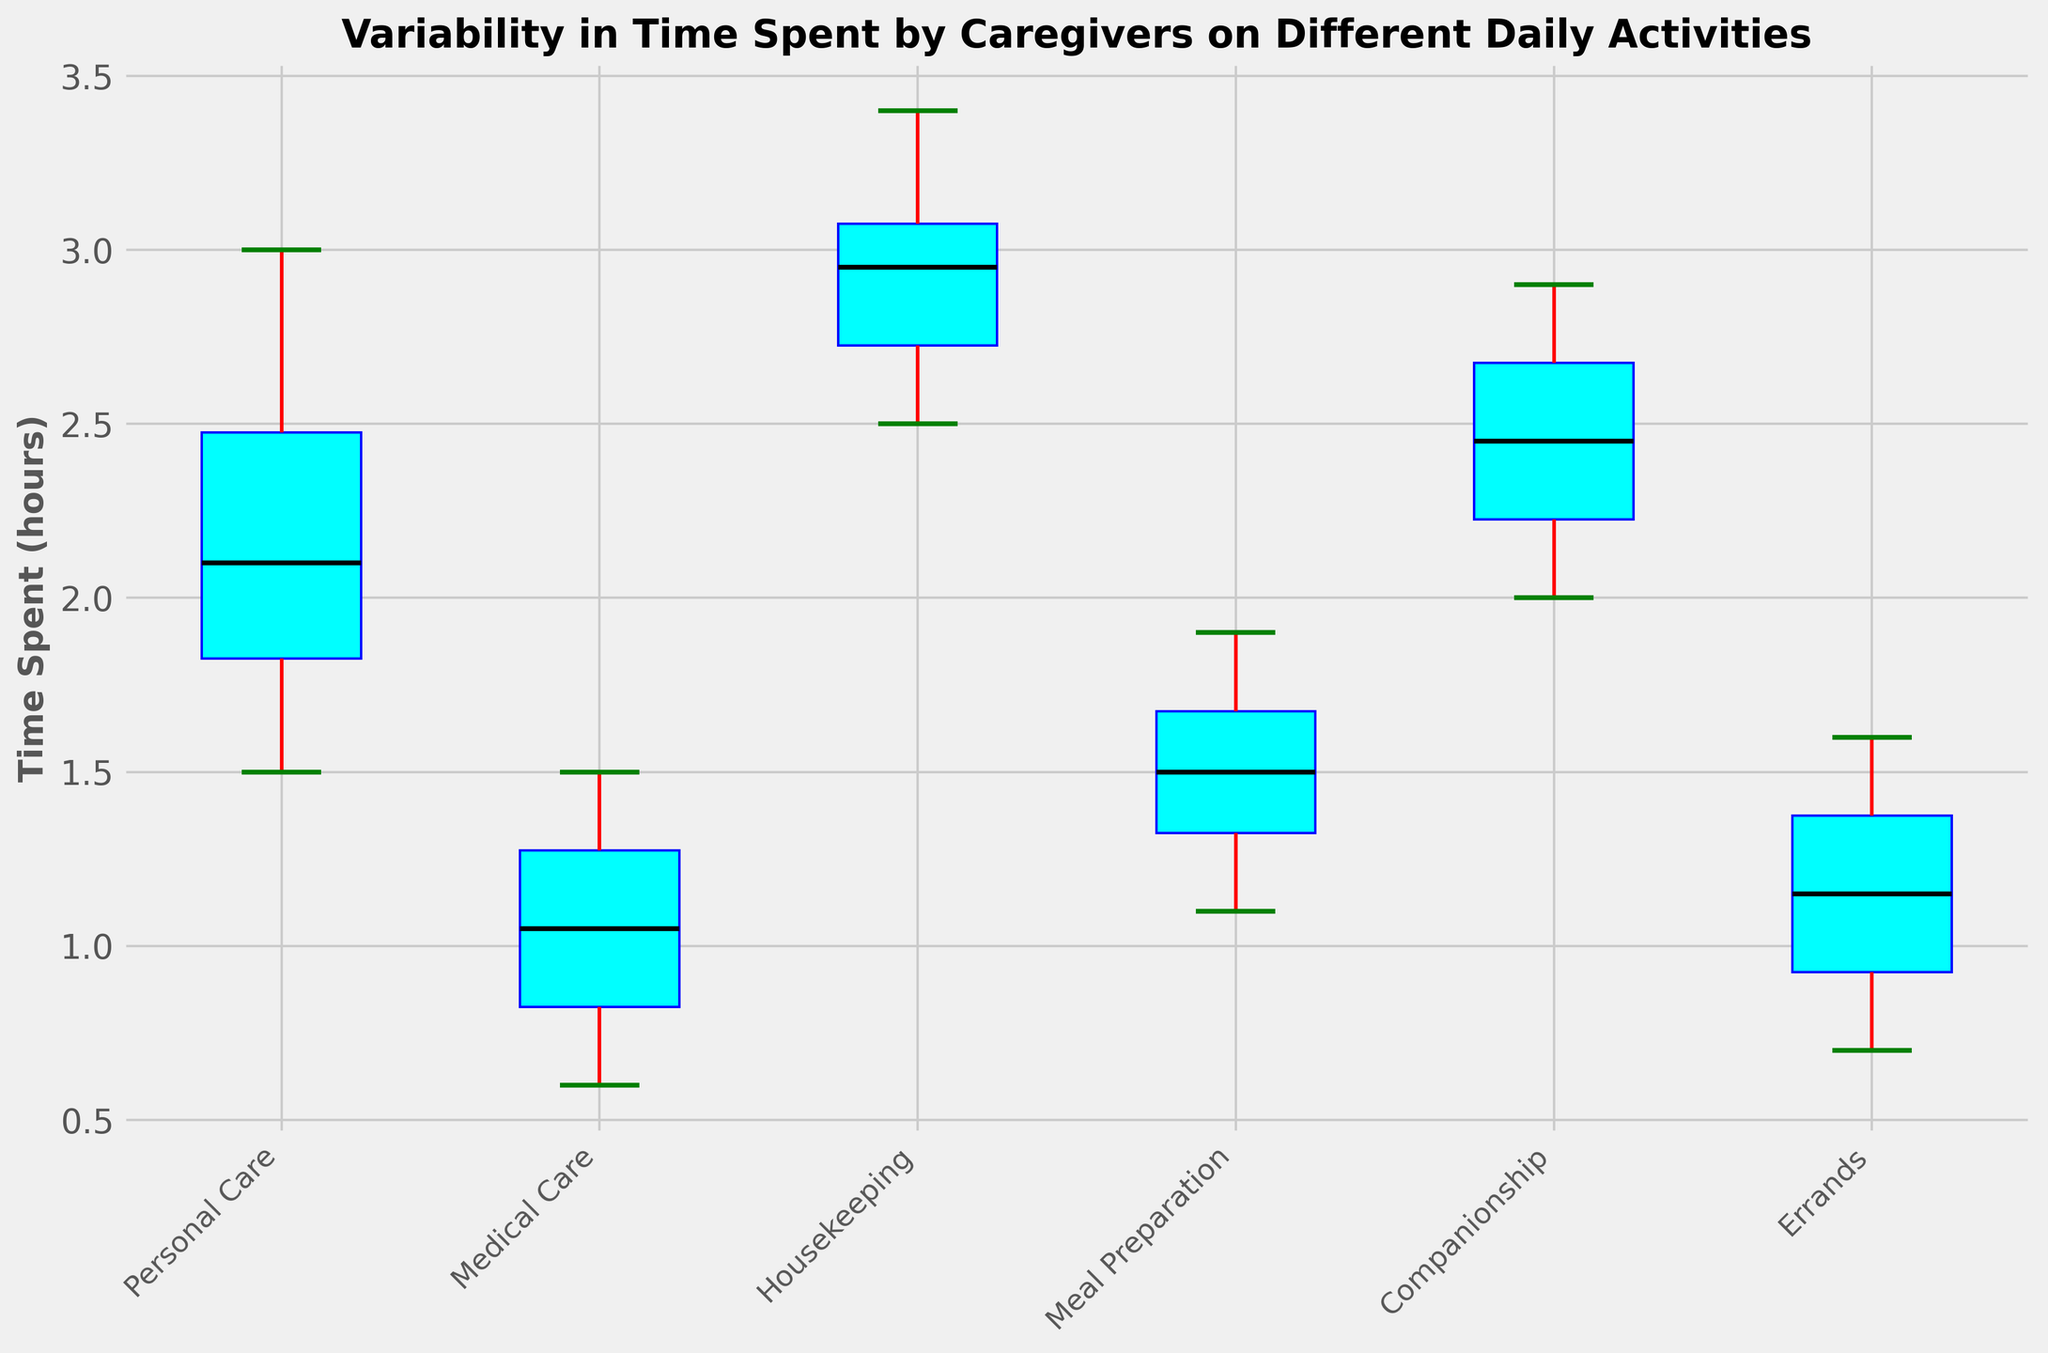Which activity has the highest median time spent by caregivers? The median is the line in the middle of each box. We compare the median lines for each activity to find the highest one.
Answer: Housekeeping Which activity has the lowest median time spent? The median line in each box plot indicates the middle value. We need to locate the activity with the lowest median.
Answer: Medical Care What is the interquartile range (IQR) for time spent on Personal Care? The IQR is the difference between the upper (75th percentile) and lower (25th percentile) quartiles. Look at the top and bottom edges of the box for Personal Care and subtract the lower from the upper quartile.
Answer: 0.8 hours (approx. 2.7 - 1.9) Which activity has the widest range of time spent (difference between minimum and maximum values)? The range is the whiskers' span (lines extending from the boxes). The activity with the longest whiskers has the widest range.
Answer: Housekeeping Is the time spent on companionship generally higher or lower than on meal preparation? Compare the median lines and the spread (IQR) of both Companionship and Meal Preparation to see if one is generally higher or lower.
Answer: Higher What percentage of data points lie within the interquartile range for each activity? By definition, 50% of the data points lie within the interquartile range (IQR) in any box plot.
Answer: 50% Which activity shows the most consistency in time spent (least variability)? Consistency is shown by the smallest IQR (the height of the box). The activity with the shortest box has the least variability.
Answer: Medical Care What is the approximate maximum time spent on medical care? The maximum value is indicated by the top whisker or any outliers above it. Look for the topmost part of Medical Care's plot.
Answer: 1.5 hours Are there any outliers in the time spent on errands? Outliers are indicated by points outside the whiskers. Look for any such points in Errands' plot.
Answer: No For which activity are the box and whiskers the most symmetrical around the median? Symmetry is judged by the evenness of the box and whiskers around the median line. The activity whose box is evenly split by the median line and has equal whiskers above and below is the most symmetrical.
Answer: Companionship 